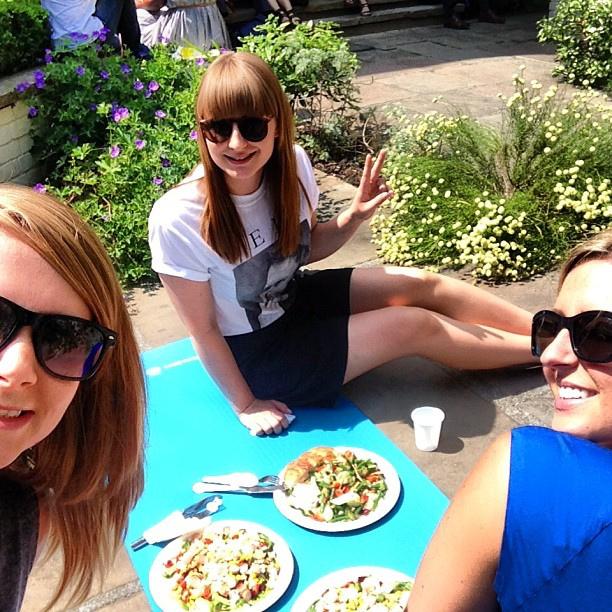Are they outside?
Short answer required. Yes. Where are the people eating?
Answer briefly. Outside. Does the food look good?
Give a very brief answer. Yes. 